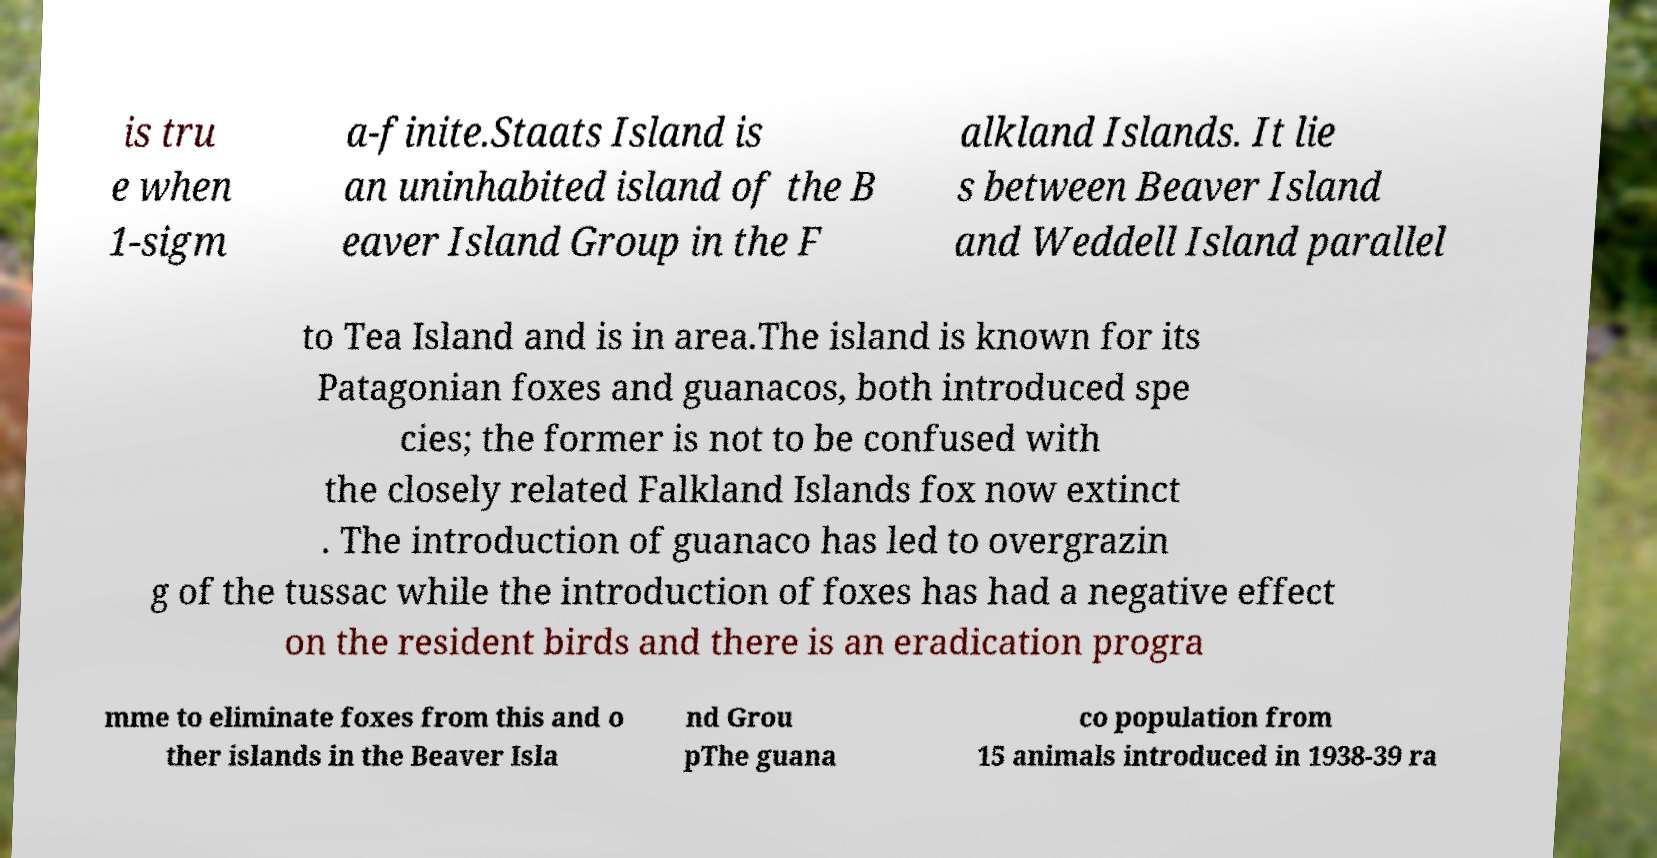I need the written content from this picture converted into text. Can you do that? is tru e when 1-sigm a-finite.Staats Island is an uninhabited island of the B eaver Island Group in the F alkland Islands. It lie s between Beaver Island and Weddell Island parallel to Tea Island and is in area.The island is known for its Patagonian foxes and guanacos, both introduced spe cies; the former is not to be confused with the closely related Falkland Islands fox now extinct . The introduction of guanaco has led to overgrazin g of the tussac while the introduction of foxes has had a negative effect on the resident birds and there is an eradication progra mme to eliminate foxes from this and o ther islands in the Beaver Isla nd Grou pThe guana co population from 15 animals introduced in 1938-39 ra 